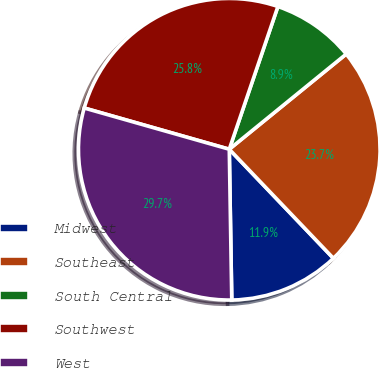<chart> <loc_0><loc_0><loc_500><loc_500><pie_chart><fcel>Midwest<fcel>Southeast<fcel>South Central<fcel>Southwest<fcel>West<nl><fcel>11.87%<fcel>23.74%<fcel>8.9%<fcel>25.82%<fcel>29.67%<nl></chart> 